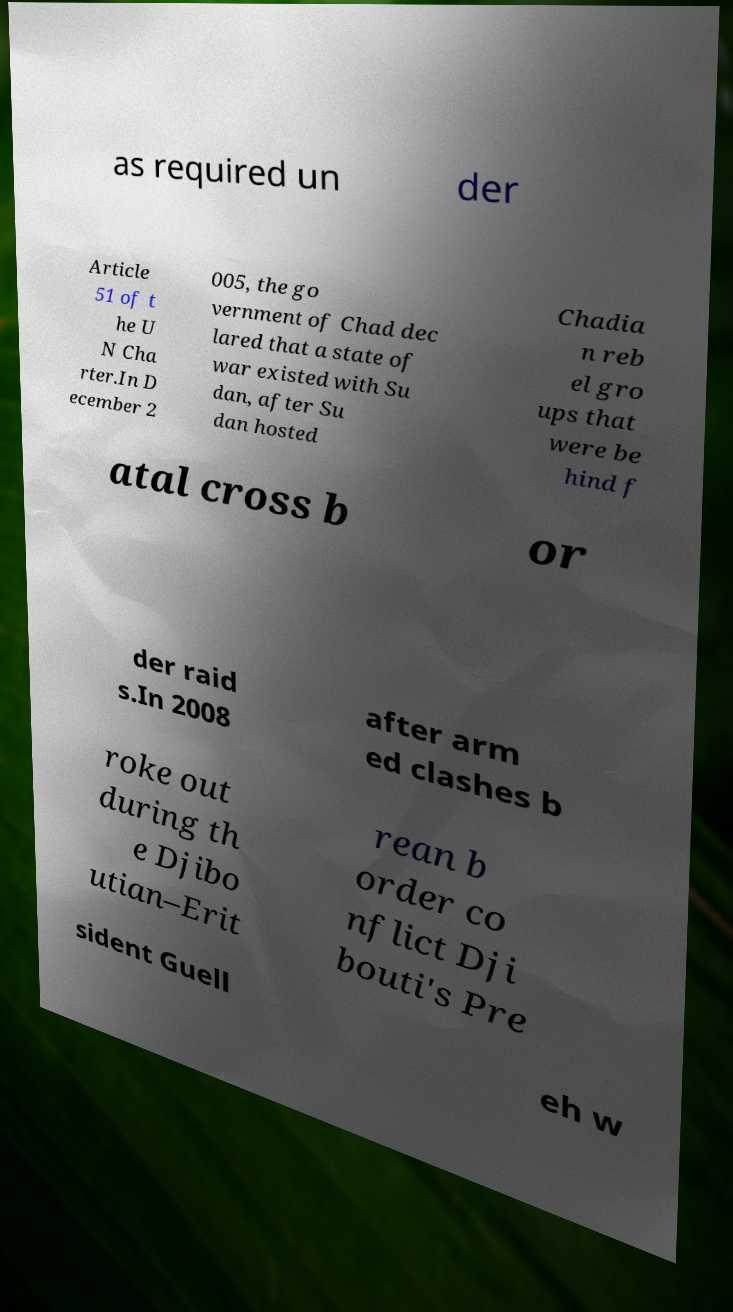Can you read and provide the text displayed in the image?This photo seems to have some interesting text. Can you extract and type it out for me? as required un der Article 51 of t he U N Cha rter.In D ecember 2 005, the go vernment of Chad dec lared that a state of war existed with Su dan, after Su dan hosted Chadia n reb el gro ups that were be hind f atal cross b or der raid s.In 2008 after arm ed clashes b roke out during th e Djibo utian–Erit rean b order co nflict Dji bouti's Pre sident Guell eh w 